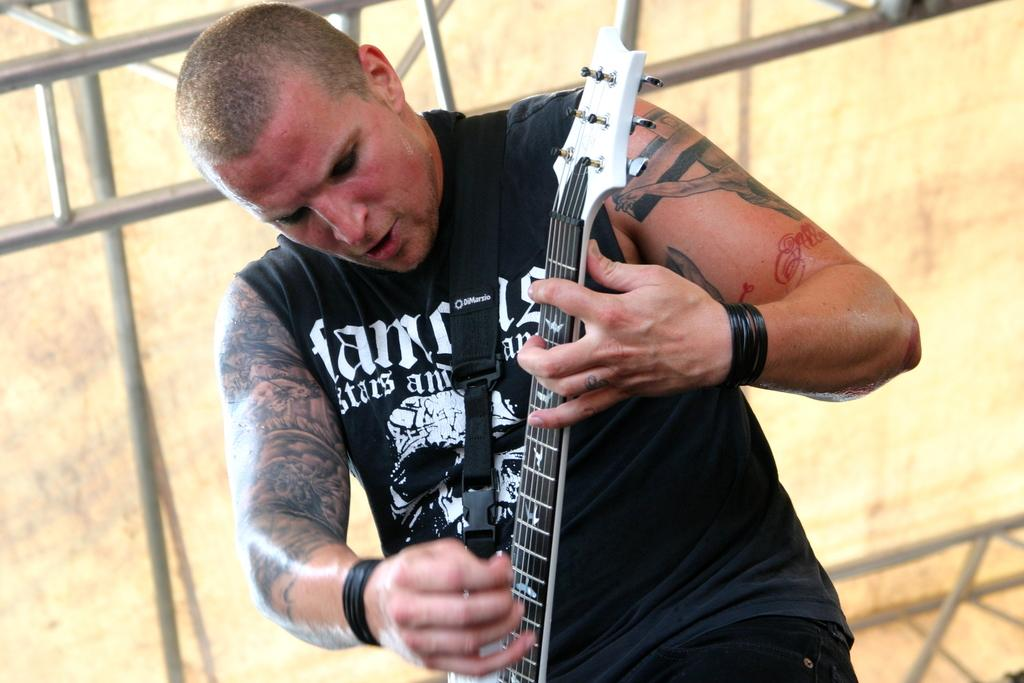What is the main subject of the image? There is a man in the image. What is the man wearing? The man is wearing a black shirt. What is the man doing in the image? The man is standing and playing a guitar. What type of glove is the man wearing in the image? There is no glove visible in the image; the man is wearing a black shirt. What process is the man performing on the lamp in the image? There is no lamp present in the image, and the man is playing a guitar, not interacting with a lamp. 